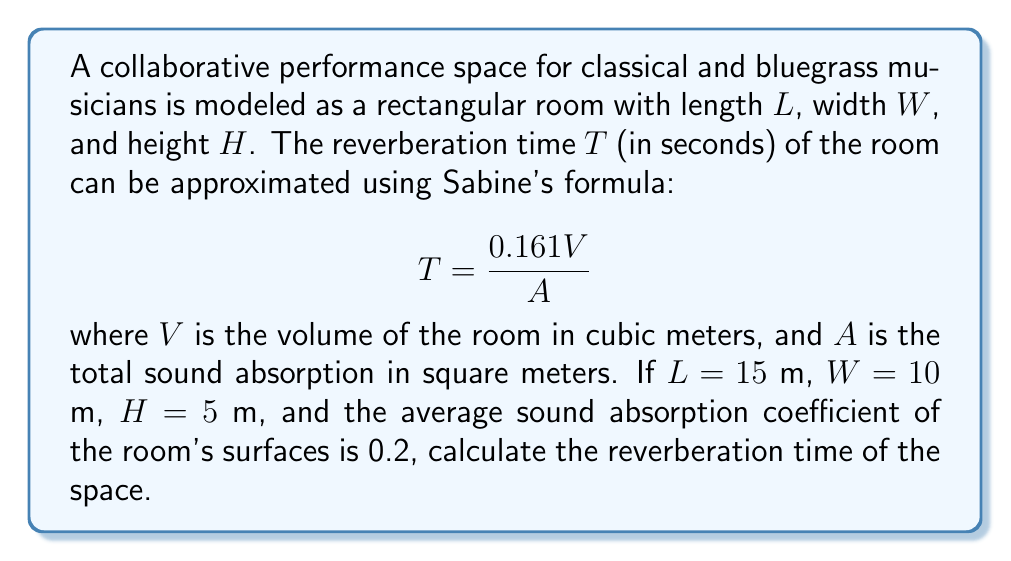Could you help me with this problem? To solve this problem, we'll follow these steps:

1. Calculate the volume of the room:
   $$V = L \times W \times H = 15 \text{ m} \times 10 \text{ m} \times 5 \text{ m} = 750 \text{ m}^3$$

2. Calculate the total surface area of the room:
   $$S = 2(LW + LH + WH) = 2(15 \times 10 + 15 \times 5 + 10 \times 5) = 550 \text{ m}^2$$

3. Calculate the total sound absorption:
   Given that the average sound absorption coefficient is 0.2,
   $$A = 0.2 \times S = 0.2 \times 550 \text{ m}^2 = 110 \text{ m}^2$$

4. Apply Sabine's formula:
   $$T = \frac{0.161V}{A} = \frac{0.161 \times 750 \text{ m}^3}{110 \text{ m}^2} \approx 1.10 \text{ s}$$

Therefore, the reverberation time of the performance space is approximately 1.10 seconds.
Answer: $1.10 \text{ s}$ 